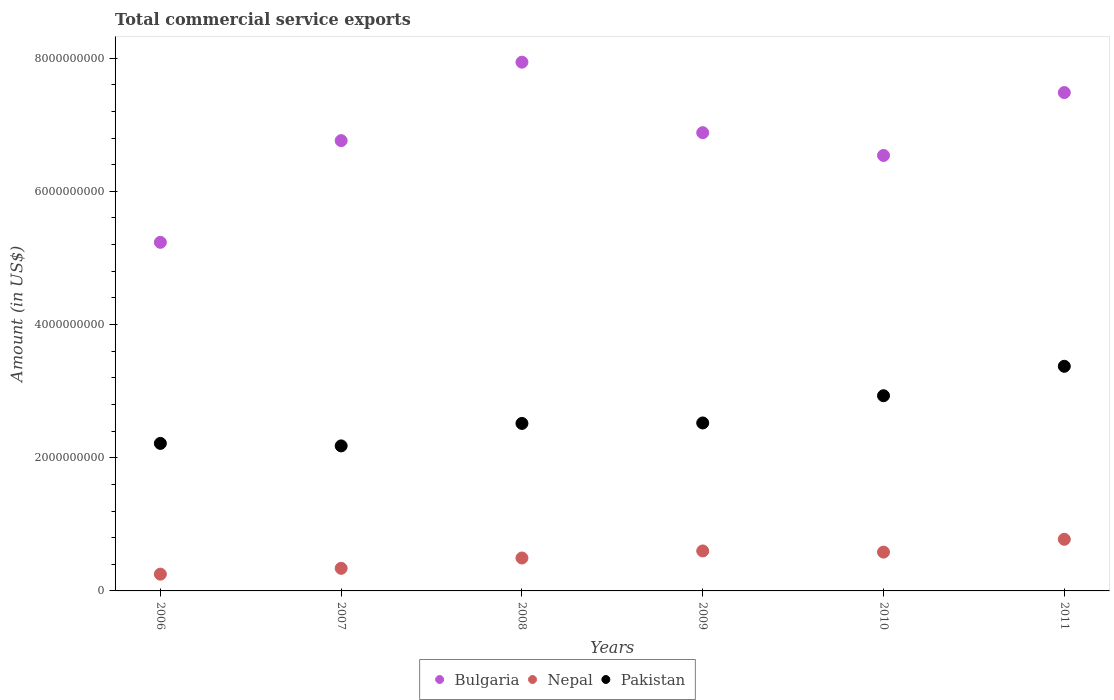What is the total commercial service exports in Pakistan in 2011?
Give a very brief answer. 3.37e+09. Across all years, what is the maximum total commercial service exports in Bulgaria?
Provide a short and direct response. 7.94e+09. Across all years, what is the minimum total commercial service exports in Pakistan?
Provide a short and direct response. 2.18e+09. In which year was the total commercial service exports in Nepal maximum?
Offer a very short reply. 2011. What is the total total commercial service exports in Bulgaria in the graph?
Provide a short and direct response. 4.08e+1. What is the difference between the total commercial service exports in Bulgaria in 2010 and that in 2011?
Provide a succinct answer. -9.44e+08. What is the difference between the total commercial service exports in Nepal in 2010 and the total commercial service exports in Bulgaria in 2008?
Your answer should be very brief. -7.36e+09. What is the average total commercial service exports in Nepal per year?
Keep it short and to the point. 5.07e+08. In the year 2010, what is the difference between the total commercial service exports in Nepal and total commercial service exports in Pakistan?
Your answer should be very brief. -2.35e+09. What is the ratio of the total commercial service exports in Pakistan in 2007 to that in 2010?
Give a very brief answer. 0.74. Is the total commercial service exports in Pakistan in 2009 less than that in 2010?
Your response must be concise. Yes. What is the difference between the highest and the second highest total commercial service exports in Bulgaria?
Give a very brief answer. 4.56e+08. What is the difference between the highest and the lowest total commercial service exports in Pakistan?
Provide a short and direct response. 1.20e+09. Is it the case that in every year, the sum of the total commercial service exports in Pakistan and total commercial service exports in Nepal  is greater than the total commercial service exports in Bulgaria?
Provide a succinct answer. No. Is the total commercial service exports in Pakistan strictly greater than the total commercial service exports in Nepal over the years?
Keep it short and to the point. Yes. How many dotlines are there?
Offer a very short reply. 3. What is the difference between two consecutive major ticks on the Y-axis?
Ensure brevity in your answer.  2.00e+09. Are the values on the major ticks of Y-axis written in scientific E-notation?
Your answer should be very brief. No. Does the graph contain any zero values?
Your answer should be very brief. No. How many legend labels are there?
Give a very brief answer. 3. How are the legend labels stacked?
Your answer should be very brief. Horizontal. What is the title of the graph?
Offer a terse response. Total commercial service exports. What is the label or title of the X-axis?
Ensure brevity in your answer.  Years. What is the Amount (in US$) in Bulgaria in 2006?
Give a very brief answer. 5.23e+09. What is the Amount (in US$) in Nepal in 2006?
Your answer should be compact. 2.52e+08. What is the Amount (in US$) of Pakistan in 2006?
Offer a terse response. 2.22e+09. What is the Amount (in US$) of Bulgaria in 2007?
Your answer should be compact. 6.76e+09. What is the Amount (in US$) of Nepal in 2007?
Offer a very short reply. 3.40e+08. What is the Amount (in US$) in Pakistan in 2007?
Offer a very short reply. 2.18e+09. What is the Amount (in US$) of Bulgaria in 2008?
Provide a succinct answer. 7.94e+09. What is the Amount (in US$) of Nepal in 2008?
Provide a short and direct response. 4.94e+08. What is the Amount (in US$) in Pakistan in 2008?
Your answer should be very brief. 2.52e+09. What is the Amount (in US$) in Bulgaria in 2009?
Give a very brief answer. 6.88e+09. What is the Amount (in US$) of Nepal in 2009?
Offer a terse response. 6.00e+08. What is the Amount (in US$) in Pakistan in 2009?
Your response must be concise. 2.52e+09. What is the Amount (in US$) in Bulgaria in 2010?
Provide a short and direct response. 6.54e+09. What is the Amount (in US$) of Nepal in 2010?
Offer a very short reply. 5.83e+08. What is the Amount (in US$) in Pakistan in 2010?
Ensure brevity in your answer.  2.93e+09. What is the Amount (in US$) of Bulgaria in 2011?
Offer a very short reply. 7.48e+09. What is the Amount (in US$) of Nepal in 2011?
Make the answer very short. 7.75e+08. What is the Amount (in US$) of Pakistan in 2011?
Your response must be concise. 3.37e+09. Across all years, what is the maximum Amount (in US$) in Bulgaria?
Make the answer very short. 7.94e+09. Across all years, what is the maximum Amount (in US$) of Nepal?
Provide a succinct answer. 7.75e+08. Across all years, what is the maximum Amount (in US$) in Pakistan?
Give a very brief answer. 3.37e+09. Across all years, what is the minimum Amount (in US$) of Bulgaria?
Your answer should be very brief. 5.23e+09. Across all years, what is the minimum Amount (in US$) in Nepal?
Your answer should be compact. 2.52e+08. Across all years, what is the minimum Amount (in US$) in Pakistan?
Your response must be concise. 2.18e+09. What is the total Amount (in US$) of Bulgaria in the graph?
Ensure brevity in your answer.  4.08e+1. What is the total Amount (in US$) in Nepal in the graph?
Give a very brief answer. 3.04e+09. What is the total Amount (in US$) of Pakistan in the graph?
Give a very brief answer. 1.57e+1. What is the difference between the Amount (in US$) in Bulgaria in 2006 and that in 2007?
Your answer should be compact. -1.53e+09. What is the difference between the Amount (in US$) in Nepal in 2006 and that in 2007?
Your answer should be compact. -8.78e+07. What is the difference between the Amount (in US$) in Pakistan in 2006 and that in 2007?
Keep it short and to the point. 3.73e+07. What is the difference between the Amount (in US$) in Bulgaria in 2006 and that in 2008?
Your answer should be compact. -2.71e+09. What is the difference between the Amount (in US$) in Nepal in 2006 and that in 2008?
Your answer should be very brief. -2.43e+08. What is the difference between the Amount (in US$) in Pakistan in 2006 and that in 2008?
Make the answer very short. -3.00e+08. What is the difference between the Amount (in US$) in Bulgaria in 2006 and that in 2009?
Keep it short and to the point. -1.65e+09. What is the difference between the Amount (in US$) in Nepal in 2006 and that in 2009?
Make the answer very short. -3.49e+08. What is the difference between the Amount (in US$) in Pakistan in 2006 and that in 2009?
Make the answer very short. -3.07e+08. What is the difference between the Amount (in US$) in Bulgaria in 2006 and that in 2010?
Ensure brevity in your answer.  -1.30e+09. What is the difference between the Amount (in US$) of Nepal in 2006 and that in 2010?
Offer a very short reply. -3.31e+08. What is the difference between the Amount (in US$) in Pakistan in 2006 and that in 2010?
Keep it short and to the point. -7.16e+08. What is the difference between the Amount (in US$) in Bulgaria in 2006 and that in 2011?
Your response must be concise. -2.25e+09. What is the difference between the Amount (in US$) in Nepal in 2006 and that in 2011?
Your response must be concise. -5.23e+08. What is the difference between the Amount (in US$) of Pakistan in 2006 and that in 2011?
Your answer should be compact. -1.16e+09. What is the difference between the Amount (in US$) in Bulgaria in 2007 and that in 2008?
Keep it short and to the point. -1.18e+09. What is the difference between the Amount (in US$) in Nepal in 2007 and that in 2008?
Your answer should be very brief. -1.55e+08. What is the difference between the Amount (in US$) in Pakistan in 2007 and that in 2008?
Give a very brief answer. -3.37e+08. What is the difference between the Amount (in US$) of Bulgaria in 2007 and that in 2009?
Provide a short and direct response. -1.19e+08. What is the difference between the Amount (in US$) in Nepal in 2007 and that in 2009?
Ensure brevity in your answer.  -2.61e+08. What is the difference between the Amount (in US$) of Pakistan in 2007 and that in 2009?
Give a very brief answer. -3.44e+08. What is the difference between the Amount (in US$) of Bulgaria in 2007 and that in 2010?
Offer a terse response. 2.23e+08. What is the difference between the Amount (in US$) of Nepal in 2007 and that in 2010?
Your answer should be very brief. -2.43e+08. What is the difference between the Amount (in US$) of Pakistan in 2007 and that in 2010?
Your answer should be very brief. -7.53e+08. What is the difference between the Amount (in US$) of Bulgaria in 2007 and that in 2011?
Keep it short and to the point. -7.22e+08. What is the difference between the Amount (in US$) in Nepal in 2007 and that in 2011?
Ensure brevity in your answer.  -4.36e+08. What is the difference between the Amount (in US$) of Pakistan in 2007 and that in 2011?
Your answer should be very brief. -1.20e+09. What is the difference between the Amount (in US$) in Bulgaria in 2008 and that in 2009?
Provide a succinct answer. 1.06e+09. What is the difference between the Amount (in US$) of Nepal in 2008 and that in 2009?
Make the answer very short. -1.06e+08. What is the difference between the Amount (in US$) of Pakistan in 2008 and that in 2009?
Provide a succinct answer. -7.00e+06. What is the difference between the Amount (in US$) in Bulgaria in 2008 and that in 2010?
Your answer should be compact. 1.40e+09. What is the difference between the Amount (in US$) of Nepal in 2008 and that in 2010?
Make the answer very short. -8.85e+07. What is the difference between the Amount (in US$) in Pakistan in 2008 and that in 2010?
Your response must be concise. -4.16e+08. What is the difference between the Amount (in US$) in Bulgaria in 2008 and that in 2011?
Offer a very short reply. 4.56e+08. What is the difference between the Amount (in US$) of Nepal in 2008 and that in 2011?
Provide a short and direct response. -2.81e+08. What is the difference between the Amount (in US$) of Pakistan in 2008 and that in 2011?
Make the answer very short. -8.58e+08. What is the difference between the Amount (in US$) of Bulgaria in 2009 and that in 2010?
Provide a succinct answer. 3.42e+08. What is the difference between the Amount (in US$) in Nepal in 2009 and that in 2010?
Keep it short and to the point. 1.74e+07. What is the difference between the Amount (in US$) of Pakistan in 2009 and that in 2010?
Your answer should be compact. -4.09e+08. What is the difference between the Amount (in US$) in Bulgaria in 2009 and that in 2011?
Give a very brief answer. -6.02e+08. What is the difference between the Amount (in US$) in Nepal in 2009 and that in 2011?
Provide a short and direct response. -1.75e+08. What is the difference between the Amount (in US$) of Pakistan in 2009 and that in 2011?
Provide a succinct answer. -8.51e+08. What is the difference between the Amount (in US$) in Bulgaria in 2010 and that in 2011?
Your answer should be compact. -9.44e+08. What is the difference between the Amount (in US$) of Nepal in 2010 and that in 2011?
Make the answer very short. -1.92e+08. What is the difference between the Amount (in US$) in Pakistan in 2010 and that in 2011?
Ensure brevity in your answer.  -4.42e+08. What is the difference between the Amount (in US$) of Bulgaria in 2006 and the Amount (in US$) of Nepal in 2007?
Offer a very short reply. 4.89e+09. What is the difference between the Amount (in US$) in Bulgaria in 2006 and the Amount (in US$) in Pakistan in 2007?
Offer a terse response. 3.06e+09. What is the difference between the Amount (in US$) of Nepal in 2006 and the Amount (in US$) of Pakistan in 2007?
Your response must be concise. -1.93e+09. What is the difference between the Amount (in US$) of Bulgaria in 2006 and the Amount (in US$) of Nepal in 2008?
Your response must be concise. 4.74e+09. What is the difference between the Amount (in US$) in Bulgaria in 2006 and the Amount (in US$) in Pakistan in 2008?
Make the answer very short. 2.72e+09. What is the difference between the Amount (in US$) of Nepal in 2006 and the Amount (in US$) of Pakistan in 2008?
Ensure brevity in your answer.  -2.26e+09. What is the difference between the Amount (in US$) of Bulgaria in 2006 and the Amount (in US$) of Nepal in 2009?
Offer a very short reply. 4.63e+09. What is the difference between the Amount (in US$) in Bulgaria in 2006 and the Amount (in US$) in Pakistan in 2009?
Your response must be concise. 2.71e+09. What is the difference between the Amount (in US$) of Nepal in 2006 and the Amount (in US$) of Pakistan in 2009?
Your answer should be compact. -2.27e+09. What is the difference between the Amount (in US$) in Bulgaria in 2006 and the Amount (in US$) in Nepal in 2010?
Make the answer very short. 4.65e+09. What is the difference between the Amount (in US$) of Bulgaria in 2006 and the Amount (in US$) of Pakistan in 2010?
Provide a short and direct response. 2.30e+09. What is the difference between the Amount (in US$) of Nepal in 2006 and the Amount (in US$) of Pakistan in 2010?
Offer a terse response. -2.68e+09. What is the difference between the Amount (in US$) in Bulgaria in 2006 and the Amount (in US$) in Nepal in 2011?
Offer a terse response. 4.46e+09. What is the difference between the Amount (in US$) of Bulgaria in 2006 and the Amount (in US$) of Pakistan in 2011?
Give a very brief answer. 1.86e+09. What is the difference between the Amount (in US$) of Nepal in 2006 and the Amount (in US$) of Pakistan in 2011?
Your answer should be very brief. -3.12e+09. What is the difference between the Amount (in US$) of Bulgaria in 2007 and the Amount (in US$) of Nepal in 2008?
Give a very brief answer. 6.27e+09. What is the difference between the Amount (in US$) in Bulgaria in 2007 and the Amount (in US$) in Pakistan in 2008?
Offer a terse response. 4.25e+09. What is the difference between the Amount (in US$) in Nepal in 2007 and the Amount (in US$) in Pakistan in 2008?
Ensure brevity in your answer.  -2.18e+09. What is the difference between the Amount (in US$) of Bulgaria in 2007 and the Amount (in US$) of Nepal in 2009?
Your answer should be very brief. 6.16e+09. What is the difference between the Amount (in US$) in Bulgaria in 2007 and the Amount (in US$) in Pakistan in 2009?
Your answer should be compact. 4.24e+09. What is the difference between the Amount (in US$) of Nepal in 2007 and the Amount (in US$) of Pakistan in 2009?
Your answer should be compact. -2.18e+09. What is the difference between the Amount (in US$) in Bulgaria in 2007 and the Amount (in US$) in Nepal in 2010?
Your answer should be compact. 6.18e+09. What is the difference between the Amount (in US$) of Bulgaria in 2007 and the Amount (in US$) of Pakistan in 2010?
Offer a very short reply. 3.83e+09. What is the difference between the Amount (in US$) in Nepal in 2007 and the Amount (in US$) in Pakistan in 2010?
Provide a succinct answer. -2.59e+09. What is the difference between the Amount (in US$) in Bulgaria in 2007 and the Amount (in US$) in Nepal in 2011?
Offer a very short reply. 5.99e+09. What is the difference between the Amount (in US$) in Bulgaria in 2007 and the Amount (in US$) in Pakistan in 2011?
Ensure brevity in your answer.  3.39e+09. What is the difference between the Amount (in US$) in Nepal in 2007 and the Amount (in US$) in Pakistan in 2011?
Provide a succinct answer. -3.03e+09. What is the difference between the Amount (in US$) of Bulgaria in 2008 and the Amount (in US$) of Nepal in 2009?
Provide a succinct answer. 7.34e+09. What is the difference between the Amount (in US$) in Bulgaria in 2008 and the Amount (in US$) in Pakistan in 2009?
Your answer should be very brief. 5.42e+09. What is the difference between the Amount (in US$) of Nepal in 2008 and the Amount (in US$) of Pakistan in 2009?
Offer a terse response. -2.03e+09. What is the difference between the Amount (in US$) of Bulgaria in 2008 and the Amount (in US$) of Nepal in 2010?
Your answer should be compact. 7.36e+09. What is the difference between the Amount (in US$) of Bulgaria in 2008 and the Amount (in US$) of Pakistan in 2010?
Your answer should be very brief. 5.01e+09. What is the difference between the Amount (in US$) of Nepal in 2008 and the Amount (in US$) of Pakistan in 2010?
Offer a very short reply. -2.44e+09. What is the difference between the Amount (in US$) in Bulgaria in 2008 and the Amount (in US$) in Nepal in 2011?
Your answer should be compact. 7.16e+09. What is the difference between the Amount (in US$) in Bulgaria in 2008 and the Amount (in US$) in Pakistan in 2011?
Your answer should be very brief. 4.57e+09. What is the difference between the Amount (in US$) in Nepal in 2008 and the Amount (in US$) in Pakistan in 2011?
Offer a very short reply. -2.88e+09. What is the difference between the Amount (in US$) in Bulgaria in 2009 and the Amount (in US$) in Nepal in 2010?
Ensure brevity in your answer.  6.30e+09. What is the difference between the Amount (in US$) of Bulgaria in 2009 and the Amount (in US$) of Pakistan in 2010?
Offer a very short reply. 3.95e+09. What is the difference between the Amount (in US$) in Nepal in 2009 and the Amount (in US$) in Pakistan in 2010?
Your response must be concise. -2.33e+09. What is the difference between the Amount (in US$) of Bulgaria in 2009 and the Amount (in US$) of Nepal in 2011?
Offer a very short reply. 6.11e+09. What is the difference between the Amount (in US$) of Bulgaria in 2009 and the Amount (in US$) of Pakistan in 2011?
Offer a terse response. 3.51e+09. What is the difference between the Amount (in US$) of Nepal in 2009 and the Amount (in US$) of Pakistan in 2011?
Provide a short and direct response. -2.77e+09. What is the difference between the Amount (in US$) in Bulgaria in 2010 and the Amount (in US$) in Nepal in 2011?
Provide a succinct answer. 5.76e+09. What is the difference between the Amount (in US$) in Bulgaria in 2010 and the Amount (in US$) in Pakistan in 2011?
Ensure brevity in your answer.  3.17e+09. What is the difference between the Amount (in US$) of Nepal in 2010 and the Amount (in US$) of Pakistan in 2011?
Give a very brief answer. -2.79e+09. What is the average Amount (in US$) in Bulgaria per year?
Keep it short and to the point. 6.81e+09. What is the average Amount (in US$) of Nepal per year?
Offer a very short reply. 5.07e+08. What is the average Amount (in US$) in Pakistan per year?
Your answer should be very brief. 2.62e+09. In the year 2006, what is the difference between the Amount (in US$) in Bulgaria and Amount (in US$) in Nepal?
Make the answer very short. 4.98e+09. In the year 2006, what is the difference between the Amount (in US$) in Bulgaria and Amount (in US$) in Pakistan?
Offer a terse response. 3.02e+09. In the year 2006, what is the difference between the Amount (in US$) in Nepal and Amount (in US$) in Pakistan?
Ensure brevity in your answer.  -1.96e+09. In the year 2007, what is the difference between the Amount (in US$) of Bulgaria and Amount (in US$) of Nepal?
Your response must be concise. 6.42e+09. In the year 2007, what is the difference between the Amount (in US$) of Bulgaria and Amount (in US$) of Pakistan?
Provide a succinct answer. 4.58e+09. In the year 2007, what is the difference between the Amount (in US$) of Nepal and Amount (in US$) of Pakistan?
Your answer should be compact. -1.84e+09. In the year 2008, what is the difference between the Amount (in US$) in Bulgaria and Amount (in US$) in Nepal?
Your answer should be very brief. 7.45e+09. In the year 2008, what is the difference between the Amount (in US$) of Bulgaria and Amount (in US$) of Pakistan?
Ensure brevity in your answer.  5.42e+09. In the year 2008, what is the difference between the Amount (in US$) in Nepal and Amount (in US$) in Pakistan?
Your answer should be very brief. -2.02e+09. In the year 2009, what is the difference between the Amount (in US$) in Bulgaria and Amount (in US$) in Nepal?
Keep it short and to the point. 6.28e+09. In the year 2009, what is the difference between the Amount (in US$) in Bulgaria and Amount (in US$) in Pakistan?
Your answer should be compact. 4.36e+09. In the year 2009, what is the difference between the Amount (in US$) of Nepal and Amount (in US$) of Pakistan?
Give a very brief answer. -1.92e+09. In the year 2010, what is the difference between the Amount (in US$) of Bulgaria and Amount (in US$) of Nepal?
Keep it short and to the point. 5.96e+09. In the year 2010, what is the difference between the Amount (in US$) of Bulgaria and Amount (in US$) of Pakistan?
Offer a very short reply. 3.61e+09. In the year 2010, what is the difference between the Amount (in US$) in Nepal and Amount (in US$) in Pakistan?
Your answer should be compact. -2.35e+09. In the year 2011, what is the difference between the Amount (in US$) of Bulgaria and Amount (in US$) of Nepal?
Offer a very short reply. 6.71e+09. In the year 2011, what is the difference between the Amount (in US$) in Bulgaria and Amount (in US$) in Pakistan?
Offer a very short reply. 4.11e+09. In the year 2011, what is the difference between the Amount (in US$) of Nepal and Amount (in US$) of Pakistan?
Offer a very short reply. -2.60e+09. What is the ratio of the Amount (in US$) of Bulgaria in 2006 to that in 2007?
Give a very brief answer. 0.77. What is the ratio of the Amount (in US$) of Nepal in 2006 to that in 2007?
Provide a short and direct response. 0.74. What is the ratio of the Amount (in US$) in Pakistan in 2006 to that in 2007?
Offer a very short reply. 1.02. What is the ratio of the Amount (in US$) of Bulgaria in 2006 to that in 2008?
Your answer should be very brief. 0.66. What is the ratio of the Amount (in US$) of Nepal in 2006 to that in 2008?
Give a very brief answer. 0.51. What is the ratio of the Amount (in US$) in Pakistan in 2006 to that in 2008?
Make the answer very short. 0.88. What is the ratio of the Amount (in US$) of Bulgaria in 2006 to that in 2009?
Your answer should be very brief. 0.76. What is the ratio of the Amount (in US$) in Nepal in 2006 to that in 2009?
Your answer should be very brief. 0.42. What is the ratio of the Amount (in US$) of Pakistan in 2006 to that in 2009?
Offer a very short reply. 0.88. What is the ratio of the Amount (in US$) in Bulgaria in 2006 to that in 2010?
Make the answer very short. 0.8. What is the ratio of the Amount (in US$) of Nepal in 2006 to that in 2010?
Your response must be concise. 0.43. What is the ratio of the Amount (in US$) in Pakistan in 2006 to that in 2010?
Provide a short and direct response. 0.76. What is the ratio of the Amount (in US$) of Bulgaria in 2006 to that in 2011?
Make the answer very short. 0.7. What is the ratio of the Amount (in US$) in Nepal in 2006 to that in 2011?
Give a very brief answer. 0.32. What is the ratio of the Amount (in US$) in Pakistan in 2006 to that in 2011?
Your response must be concise. 0.66. What is the ratio of the Amount (in US$) of Bulgaria in 2007 to that in 2008?
Your answer should be compact. 0.85. What is the ratio of the Amount (in US$) in Nepal in 2007 to that in 2008?
Your answer should be very brief. 0.69. What is the ratio of the Amount (in US$) of Pakistan in 2007 to that in 2008?
Your response must be concise. 0.87. What is the ratio of the Amount (in US$) of Bulgaria in 2007 to that in 2009?
Ensure brevity in your answer.  0.98. What is the ratio of the Amount (in US$) in Nepal in 2007 to that in 2009?
Offer a very short reply. 0.57. What is the ratio of the Amount (in US$) of Pakistan in 2007 to that in 2009?
Ensure brevity in your answer.  0.86. What is the ratio of the Amount (in US$) in Bulgaria in 2007 to that in 2010?
Your response must be concise. 1.03. What is the ratio of the Amount (in US$) of Nepal in 2007 to that in 2010?
Give a very brief answer. 0.58. What is the ratio of the Amount (in US$) of Pakistan in 2007 to that in 2010?
Offer a terse response. 0.74. What is the ratio of the Amount (in US$) of Bulgaria in 2007 to that in 2011?
Ensure brevity in your answer.  0.9. What is the ratio of the Amount (in US$) of Nepal in 2007 to that in 2011?
Ensure brevity in your answer.  0.44. What is the ratio of the Amount (in US$) in Pakistan in 2007 to that in 2011?
Provide a succinct answer. 0.65. What is the ratio of the Amount (in US$) of Bulgaria in 2008 to that in 2009?
Offer a very short reply. 1.15. What is the ratio of the Amount (in US$) of Nepal in 2008 to that in 2009?
Offer a terse response. 0.82. What is the ratio of the Amount (in US$) of Pakistan in 2008 to that in 2009?
Ensure brevity in your answer.  1. What is the ratio of the Amount (in US$) of Bulgaria in 2008 to that in 2010?
Your response must be concise. 1.21. What is the ratio of the Amount (in US$) of Nepal in 2008 to that in 2010?
Your answer should be very brief. 0.85. What is the ratio of the Amount (in US$) in Pakistan in 2008 to that in 2010?
Offer a very short reply. 0.86. What is the ratio of the Amount (in US$) of Bulgaria in 2008 to that in 2011?
Offer a terse response. 1.06. What is the ratio of the Amount (in US$) in Nepal in 2008 to that in 2011?
Make the answer very short. 0.64. What is the ratio of the Amount (in US$) in Pakistan in 2008 to that in 2011?
Make the answer very short. 0.75. What is the ratio of the Amount (in US$) of Bulgaria in 2009 to that in 2010?
Provide a short and direct response. 1.05. What is the ratio of the Amount (in US$) of Nepal in 2009 to that in 2010?
Your answer should be compact. 1.03. What is the ratio of the Amount (in US$) of Pakistan in 2009 to that in 2010?
Your answer should be compact. 0.86. What is the ratio of the Amount (in US$) of Bulgaria in 2009 to that in 2011?
Provide a short and direct response. 0.92. What is the ratio of the Amount (in US$) in Nepal in 2009 to that in 2011?
Ensure brevity in your answer.  0.77. What is the ratio of the Amount (in US$) of Pakistan in 2009 to that in 2011?
Offer a very short reply. 0.75. What is the ratio of the Amount (in US$) of Bulgaria in 2010 to that in 2011?
Your answer should be compact. 0.87. What is the ratio of the Amount (in US$) of Nepal in 2010 to that in 2011?
Give a very brief answer. 0.75. What is the ratio of the Amount (in US$) of Pakistan in 2010 to that in 2011?
Provide a succinct answer. 0.87. What is the difference between the highest and the second highest Amount (in US$) of Bulgaria?
Provide a short and direct response. 4.56e+08. What is the difference between the highest and the second highest Amount (in US$) of Nepal?
Provide a succinct answer. 1.75e+08. What is the difference between the highest and the second highest Amount (in US$) of Pakistan?
Make the answer very short. 4.42e+08. What is the difference between the highest and the lowest Amount (in US$) in Bulgaria?
Provide a short and direct response. 2.71e+09. What is the difference between the highest and the lowest Amount (in US$) of Nepal?
Your answer should be very brief. 5.23e+08. What is the difference between the highest and the lowest Amount (in US$) in Pakistan?
Your answer should be very brief. 1.20e+09. 